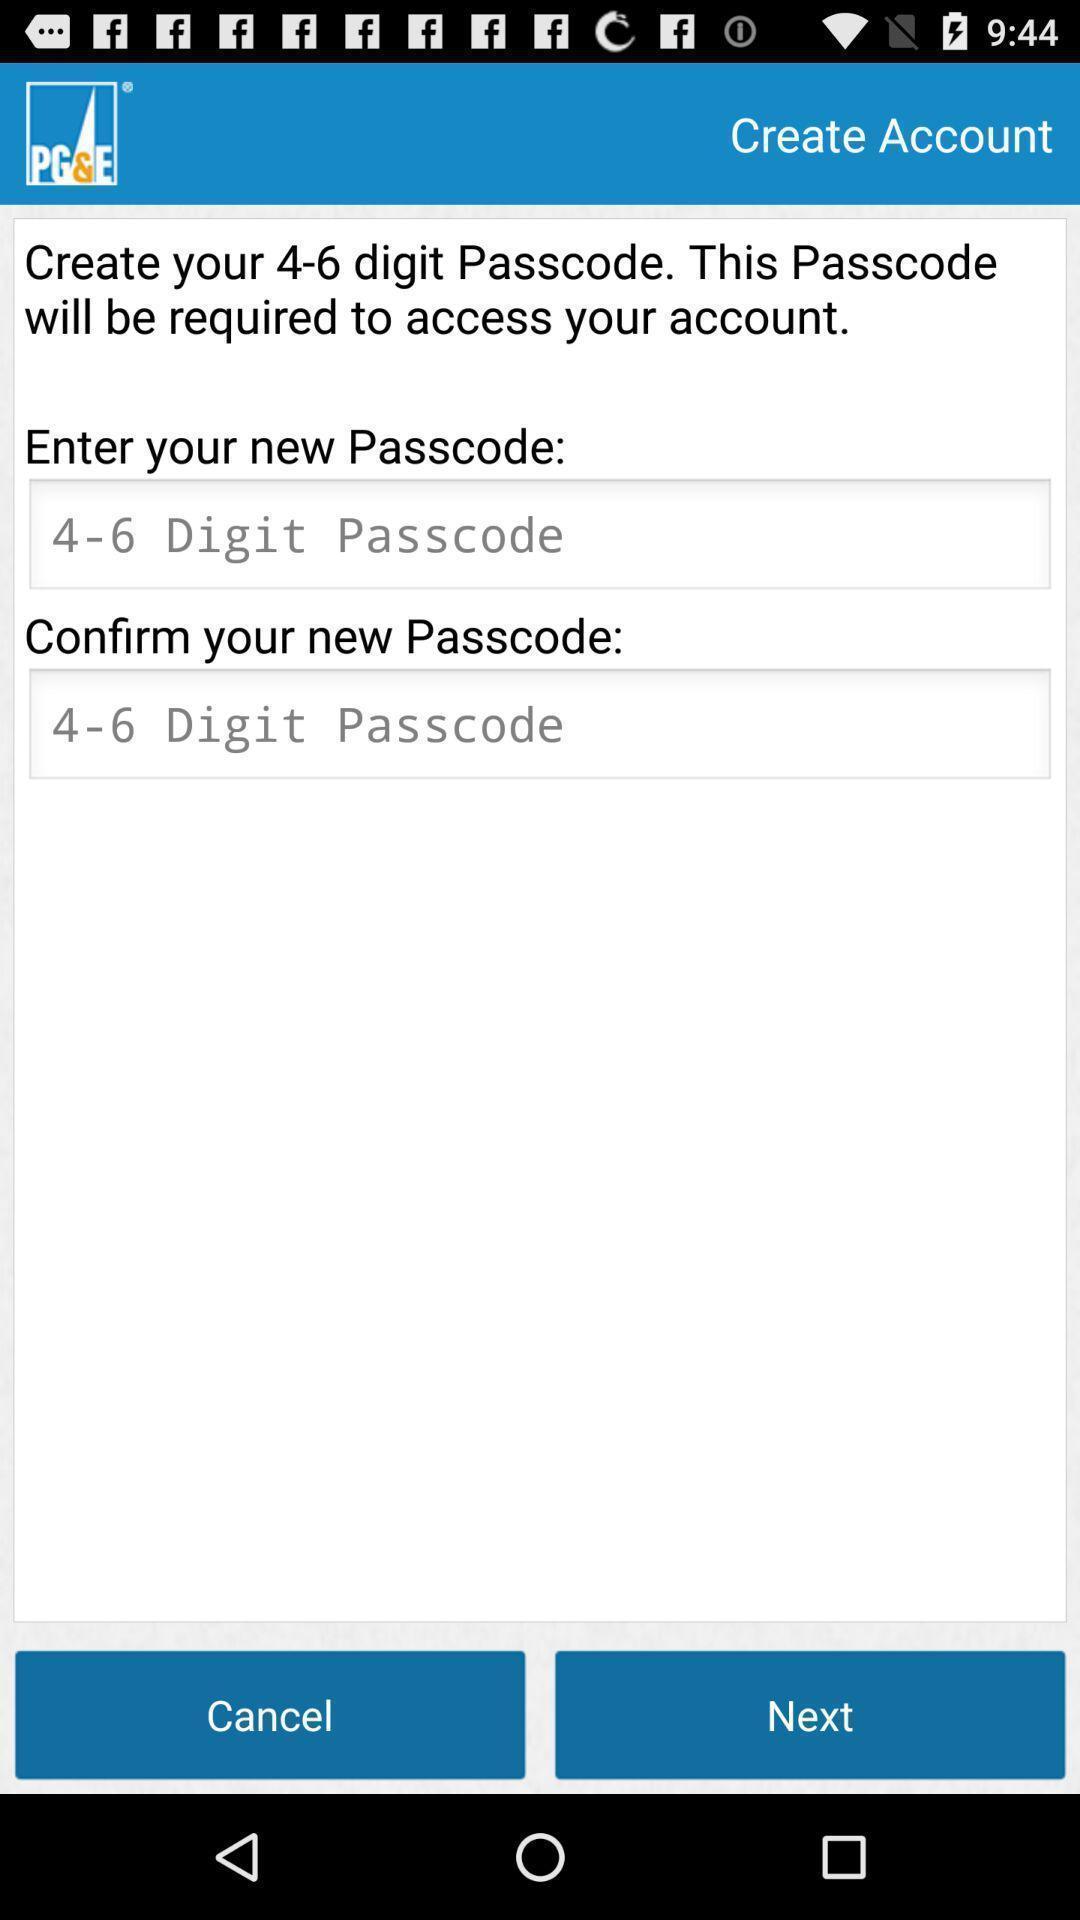Describe the visual elements of this screenshot. Page for creating the account. 